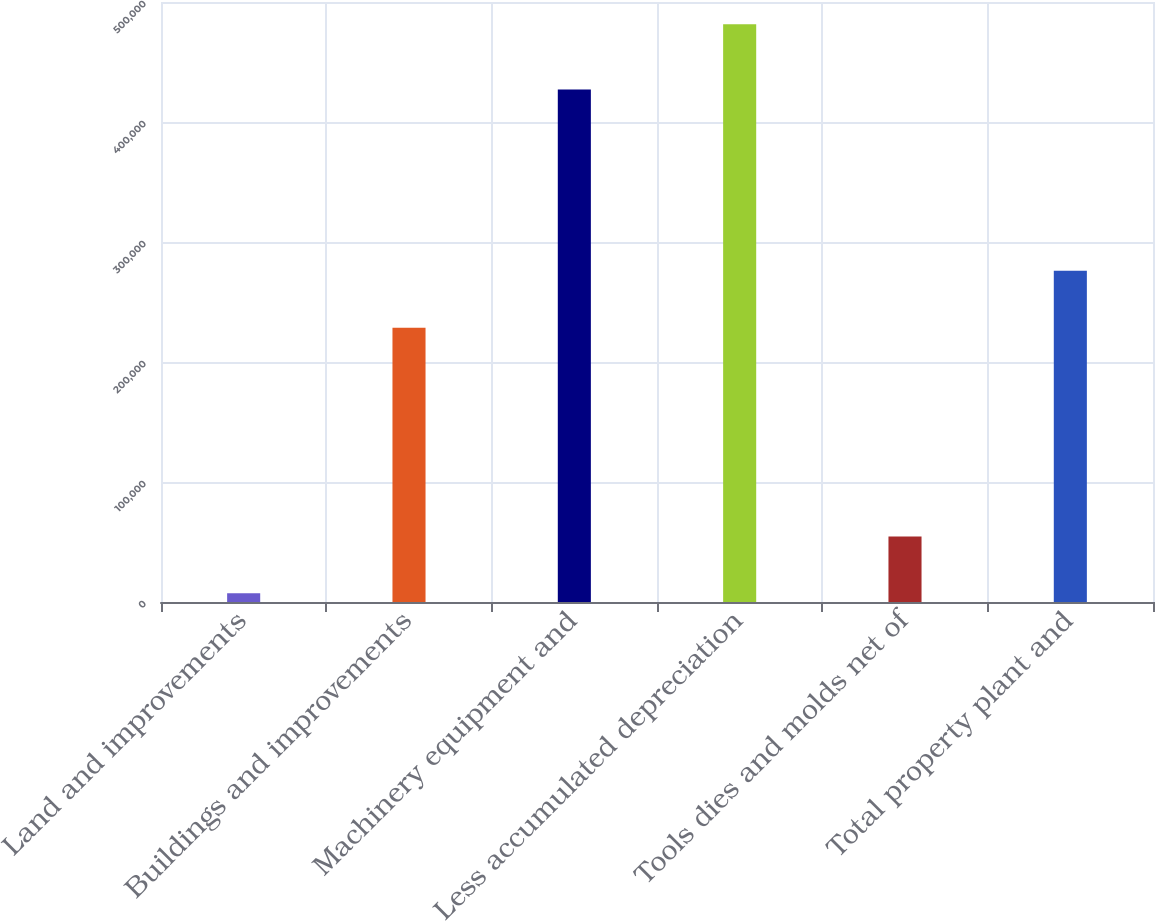<chart> <loc_0><loc_0><loc_500><loc_500><bar_chart><fcel>Land and improvements<fcel>Buildings and improvements<fcel>Machinery equipment and<fcel>Less accumulated depreciation<fcel>Tools dies and molds net of<fcel>Total property plant and<nl><fcel>7197<fcel>228611<fcel>426992<fcel>481513<fcel>54628.6<fcel>276043<nl></chart> 